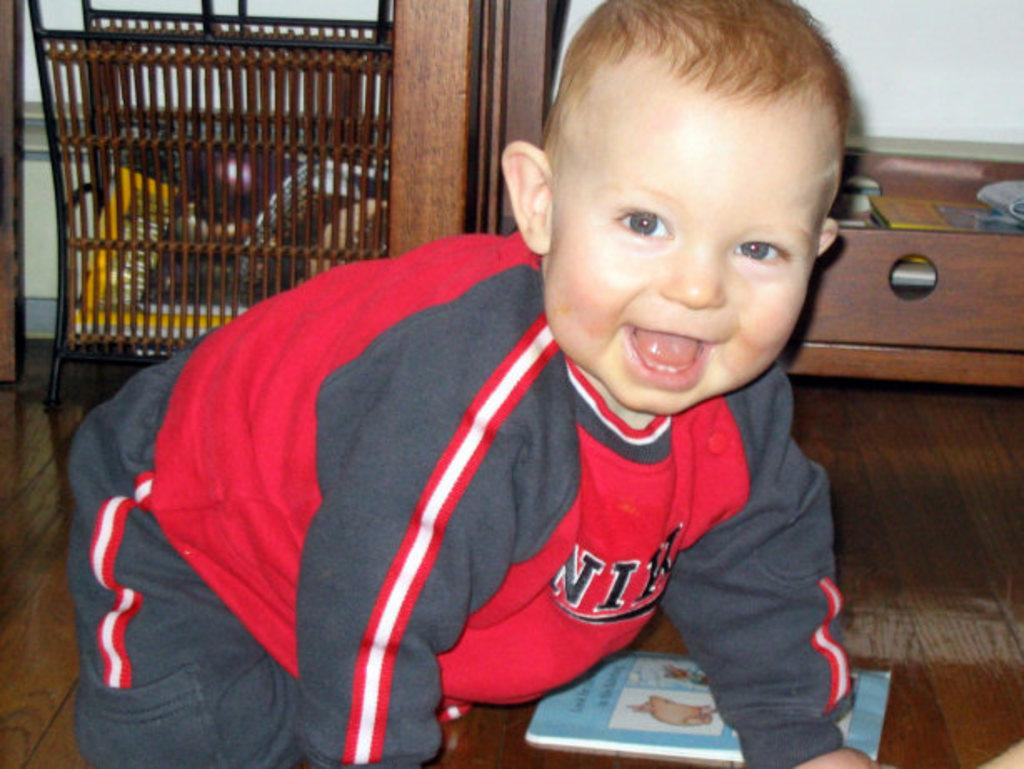Provide a one-sentence caption for the provided image. a baby crawling around the ground the the letter N on it. 